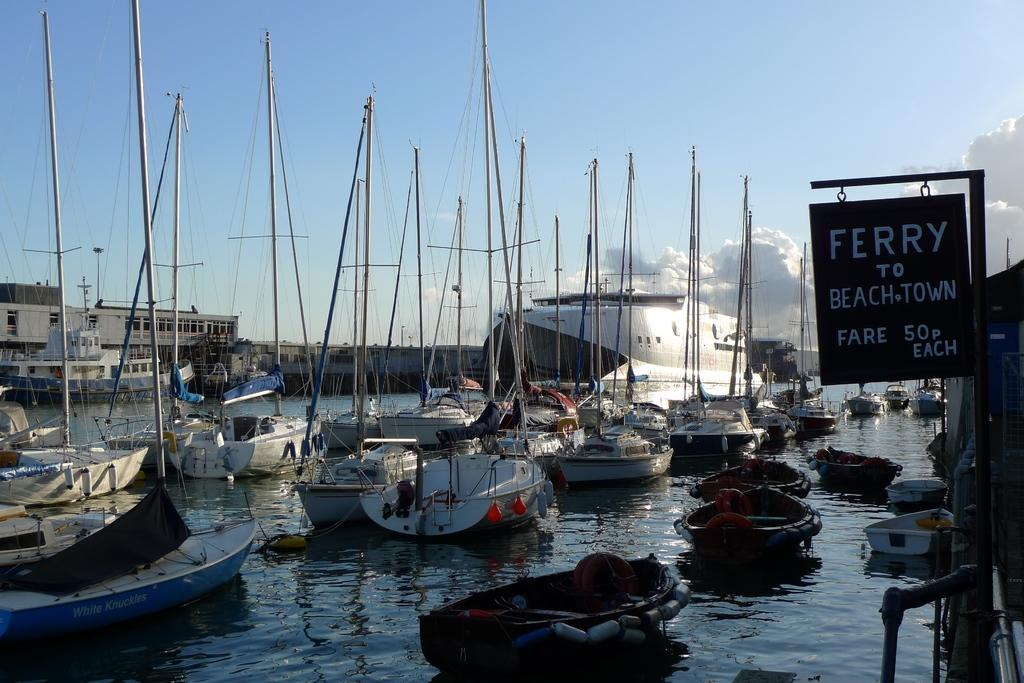Provide a one-sentence caption for the provided image. A sign next to the water reads ferry to beach town. 